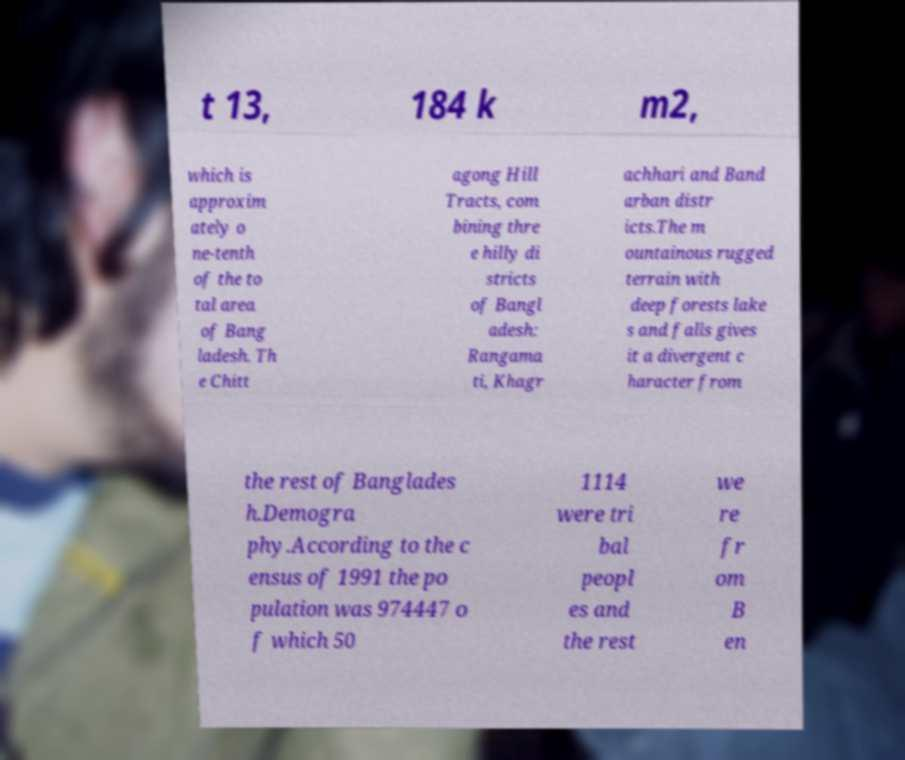Could you extract and type out the text from this image? t 13, 184 k m2, which is approxim ately o ne-tenth of the to tal area of Bang ladesh. Th e Chitt agong Hill Tracts, com bining thre e hilly di stricts of Bangl adesh: Rangama ti, Khagr achhari and Band arban distr icts.The m ountainous rugged terrain with deep forests lake s and falls gives it a divergent c haracter from the rest of Banglades h.Demogra phy.According to the c ensus of 1991 the po pulation was 974447 o f which 50 1114 were tri bal peopl es and the rest we re fr om B en 